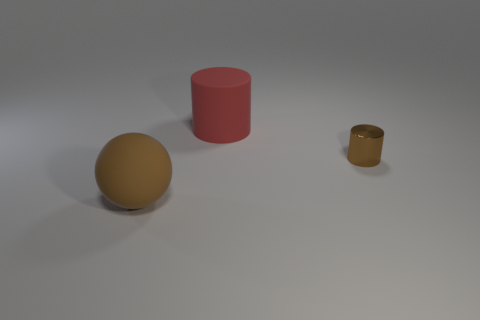There is a large brown thing that is the same material as the large red cylinder; what is its shape?
Provide a succinct answer. Sphere. The brown matte object is what shape?
Give a very brief answer. Sphere. There is a thing that is both in front of the red matte thing and on the left side of the tiny brown object; what is its color?
Ensure brevity in your answer.  Brown. What shape is the red thing that is the same size as the brown ball?
Your answer should be compact. Cylinder. Is there a brown object of the same shape as the large red thing?
Give a very brief answer. Yes. Is the material of the large red thing the same as the large object on the left side of the big red matte thing?
Provide a short and direct response. Yes. There is a large matte thing left of the big object that is right of the brown thing that is to the left of the small shiny cylinder; what is its color?
Provide a short and direct response. Brown. There is a sphere that is the same size as the red cylinder; what material is it?
Offer a terse response. Rubber. How many tiny brown things are the same material as the brown cylinder?
Provide a short and direct response. 0. There is a brown thing to the right of the brown ball; is it the same size as the matte thing that is on the left side of the red matte cylinder?
Ensure brevity in your answer.  No. 